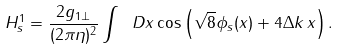Convert formula to latex. <formula><loc_0><loc_0><loc_500><loc_500>H _ { s } ^ { 1 } = \frac { 2 g _ { 1 \perp } } { ( 2 \pi \eta ) ^ { 2 } } \int \ D x \cos \left ( \sqrt { 8 } \phi _ { s } ( x ) + 4 \Delta k \, x \right ) .</formula> 